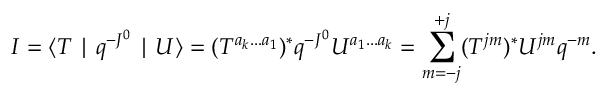Convert formula to latex. <formula><loc_0><loc_0><loc_500><loc_500>I = \langle T | q ^ { - J ^ { 0 } } | U \rangle = ( T ^ { a _ { k } \dots a _ { 1 } } ) ^ { \ast } q ^ { - J ^ { 0 } } U ^ { a _ { 1 } \dots a _ { k } } = \sum _ { m = - j } ^ { + j } ( T ^ { j m } ) ^ { \ast } U ^ { j m } q ^ { - m } .</formula> 